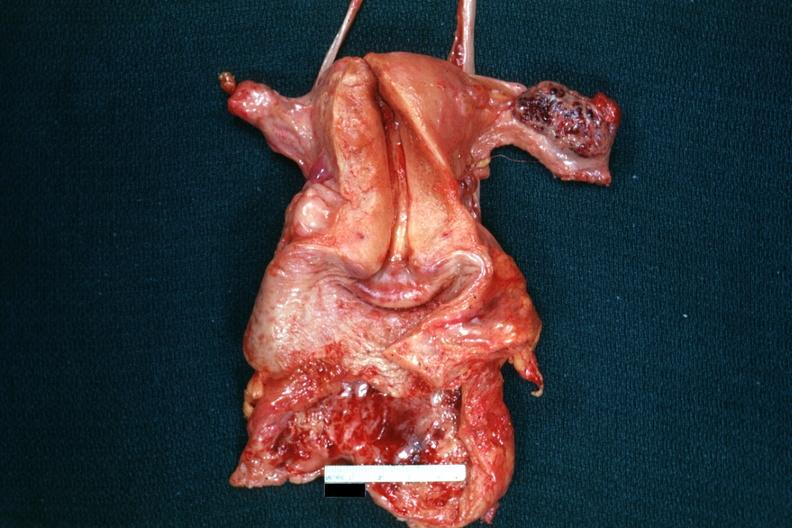where does this belong to?
Answer the question using a single word or phrase. Female reproductive system 